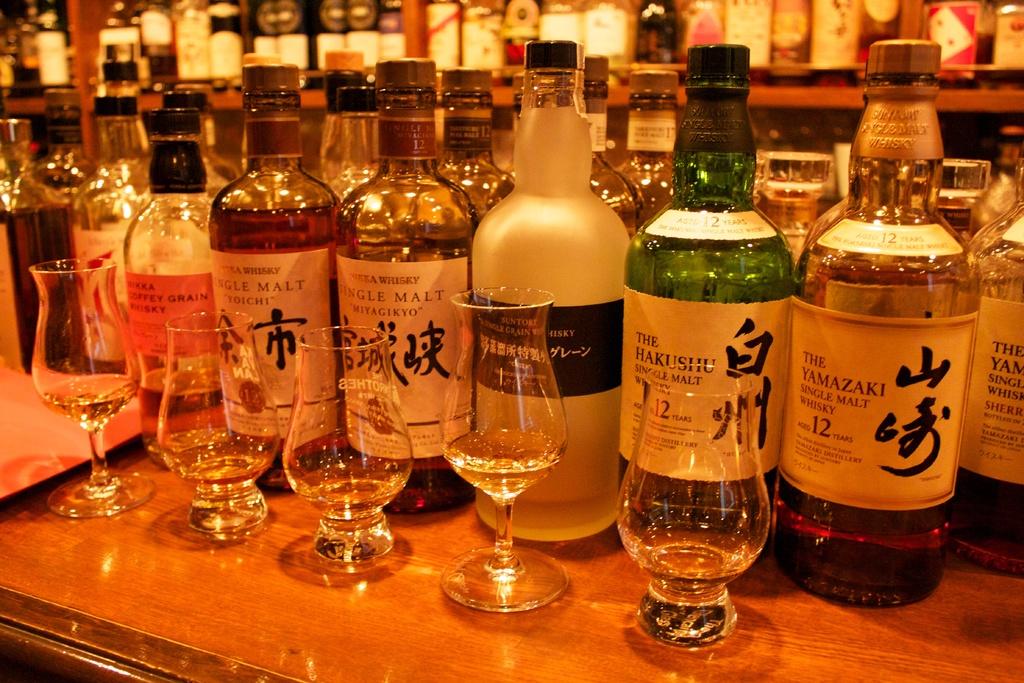What type of alcohol is in the bottle on the front-right?
Your answer should be very brief. Whiskey. For how many years is the drink in the right barreled?
Your answer should be compact. 12. 